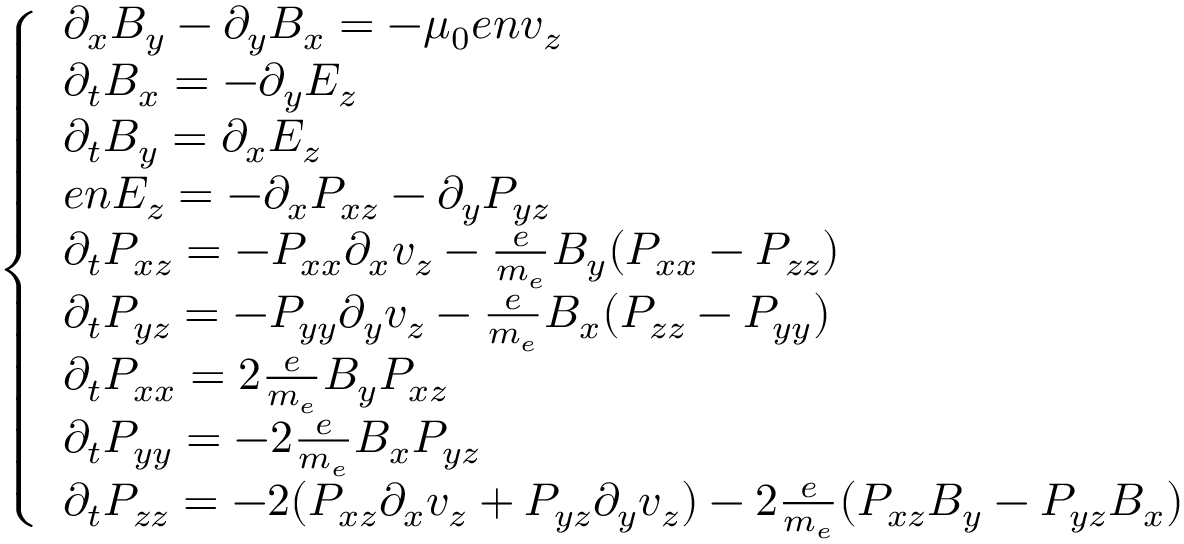Convert formula to latex. <formula><loc_0><loc_0><loc_500><loc_500>\begin{array} { r } { \left \{ \begin{array} { l l } { \partial _ { x } B _ { y } - \partial _ { y } B _ { x } = - \mu _ { 0 } e n v _ { z } } \\ { \partial _ { t } B _ { x } = - \partial _ { y } E _ { z } } \\ { \partial _ { t } B _ { y } = \partial _ { x } E _ { z } } \\ { e n E _ { z } = - \partial _ { x } P _ { x z } - \partial _ { y } P _ { y z } } \\ { \partial _ { t } P _ { x z } = - P _ { x x } \partial _ { x } v _ { z } - \frac { e } { m _ { e } } B _ { y } ( P _ { x x } - P _ { z z } ) } \\ { \partial _ { t } P _ { y z } = - P _ { y y } \partial _ { y } v _ { z } - \frac { e } { m _ { e } } B _ { x } ( P _ { z z } - P _ { y y } ) } \\ { \partial _ { t } P _ { x x } = 2 \frac { e } { m _ { e } } B _ { y } P _ { x z } } \\ { \partial _ { t } P _ { y y } = - 2 \frac { e } { m _ { e } } B _ { x } P _ { y z } } \\ { \partial _ { t } P _ { z z } = - 2 ( P _ { x z } \partial _ { x } v _ { z } + P _ { y z } \partial _ { y } v _ { z } ) - 2 \frac { e } { m _ { e } } ( P _ { x z } B _ { y } - P _ { y z } B _ { x } ) } \end{array} } \end{array}</formula> 